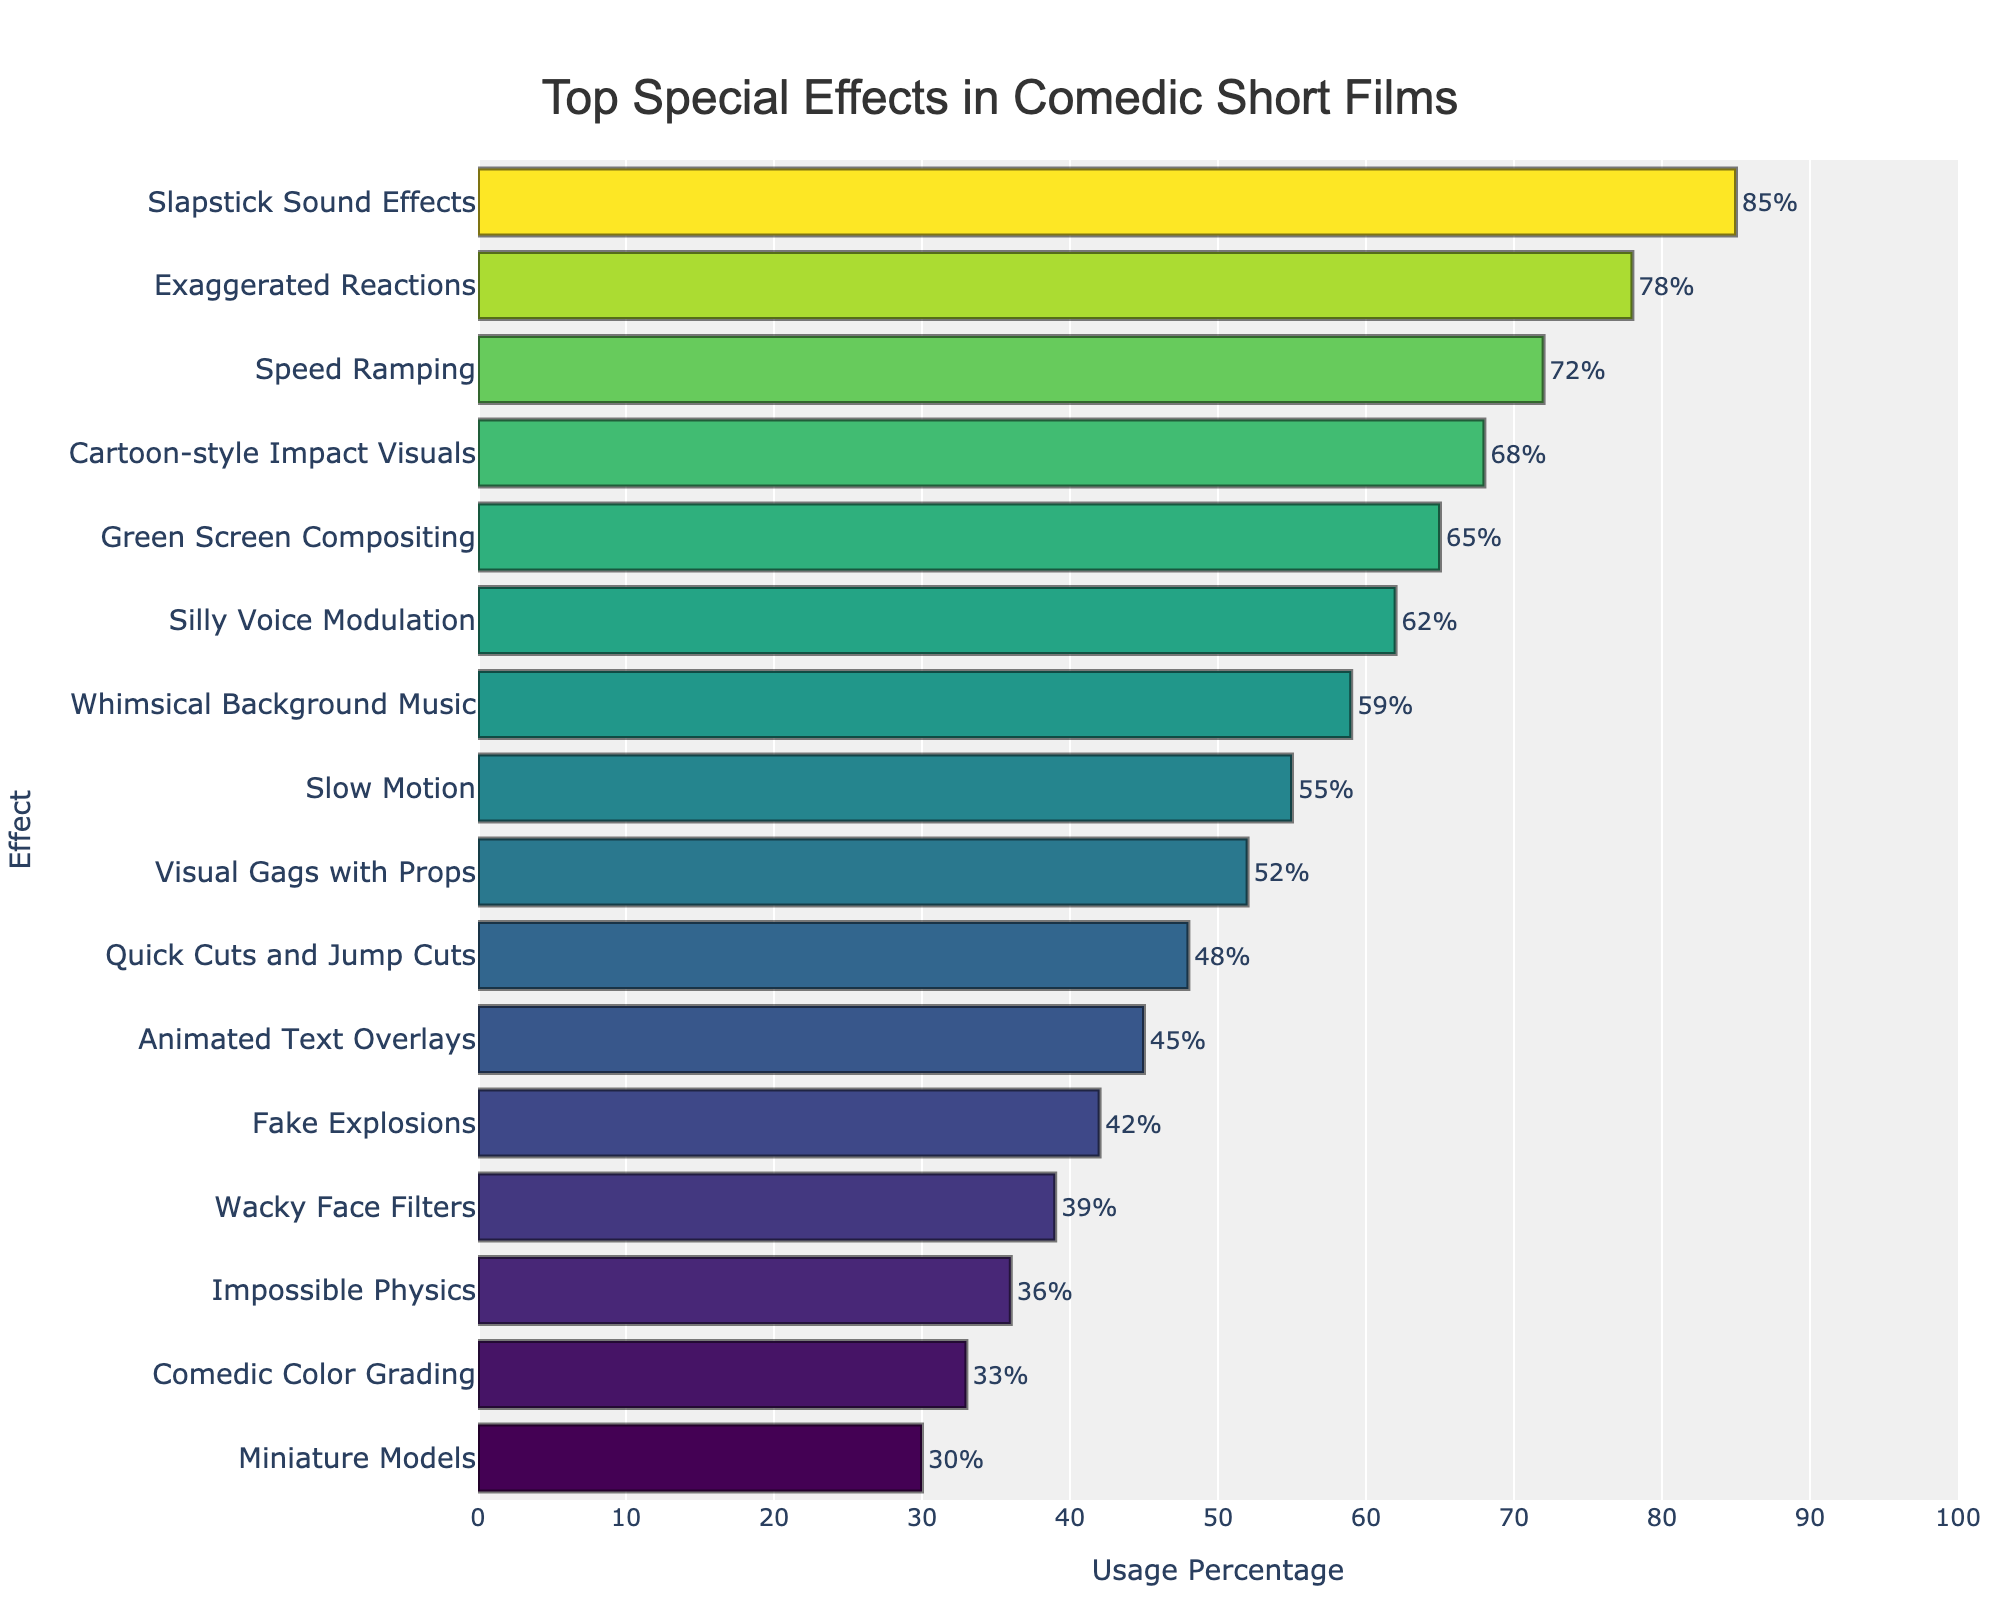Which effect is used the most in comedic short films? The top bar represents the effect most frequently used. According to the chart, the effect with the highest usage percentage is "Slapstick Sound Effects" at 85%.
Answer: Slapstick Sound Effects How much more frequently is "Exaggerated Reactions" used compared to "Quick Cuts and Jump Cuts"? To determine the difference, subtract the "Quick Cuts and Jump Cuts" usage percentage (48%) from the "Exaggerated Reactions" usage percentage (78%). 78% - 48% = 30%.
Answer: 30% Which effect barely missed the Top 10 list, based on usage percentage? Observing the sorted data, "Animated Text Overlays" just made it into the Top 10 at 45%, so the next effect "Fake Explosions" at 42% barely missed the Top 10.
Answer: Fake Explosions Which effect contributes the least to the comedic short films? The lowest bar in the chart corresponds to the least frequently used effect. "Miniature Models" has the lowest usage percentage at 30%.
Answer: Miniature Models What is the average usage percentage for the top three effects? The top three effects are "Slapstick Sound Effects" (85%), "Exaggerated Reactions" (78%), and "Speed Ramping" (72%). Calculate their average by summing these values and dividing by 3: (85 + 78 + 72) / 3 = 78.33%.
Answer: 78.33% Which two effects have a usage difference closest to 10%? Comparing pairs of effects: "Green Screen Compositing" (65%) and "Silly Voice Modulation" (62%) have a 3% difference, "Speed Ramping" (72%) and "Cartoon-style Impact Visuals" (68%) have a 4% difference, and so forth. "Whimsical Background Music" (59%) and "Slow Motion" (55%) have a 4% difference, and "Whimsical Background Music" (59%) and "Visual Gags with Props" (52%) have a 7% difference. None exactly match 10%, but the closest is 3%.
Answer: Green Screen Compositing and Silly Voice Modulation What is the total percentage usage for effects ranked 4th to 6th? The 4th to 6th ranked effects are "Cartoon-style Impact Visuals" (68%), "Green Screen Compositing" (65%), and "Silly Voice Modulation" (62%). Add these percentages: 68 + 65 + 62 = 195%.
Answer: 195% Do "Impossible Physics" and "Miniature Models" have a combined usage percentage greater than 60%? Add the usage percentages for "Impossible Physics" (36%) and "Miniature Models" (30%). Their combined usage is 36% + 30% = 66%, which is greater than 60%.
Answer: Yes Which effect stands out visually in the chart due to its color and position? The top effect visually stands out by being the longest bar, which typically uses the most saturated color in a gradient color scheme. "Slapstick Sound Effects" at 85% visually stands out.
Answer: Slapstick Sound Effects 